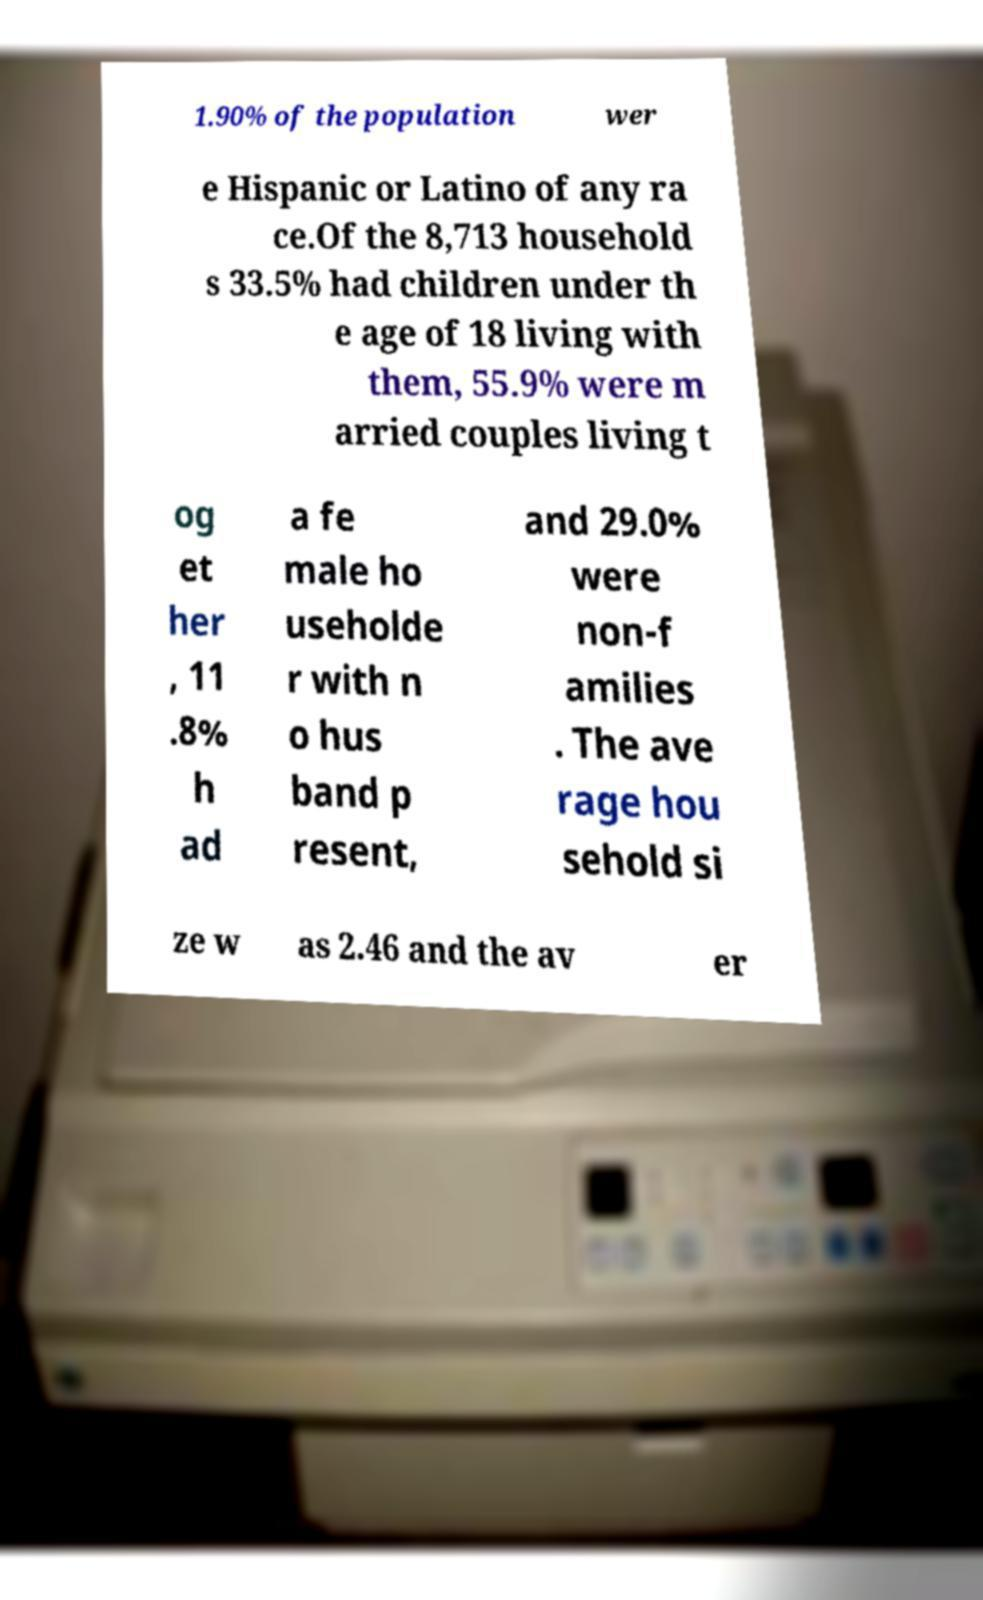Could you assist in decoding the text presented in this image and type it out clearly? 1.90% of the population wer e Hispanic or Latino of any ra ce.Of the 8,713 household s 33.5% had children under th e age of 18 living with them, 55.9% were m arried couples living t og et her , 11 .8% h ad a fe male ho useholde r with n o hus band p resent, and 29.0% were non-f amilies . The ave rage hou sehold si ze w as 2.46 and the av er 